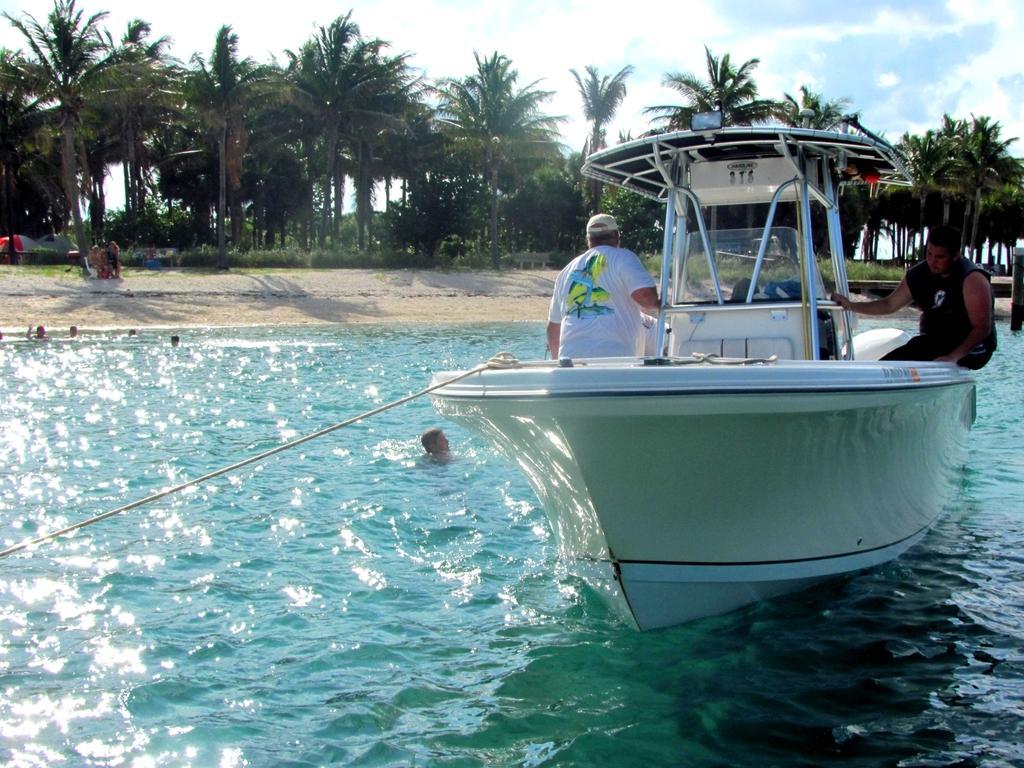Could you give a brief overview of what you see in this image? In this picture we can observe a boat floating on the water. There are some people swimming in the water. In the background there are trees and plants. We can observe a sky with some clouds. 